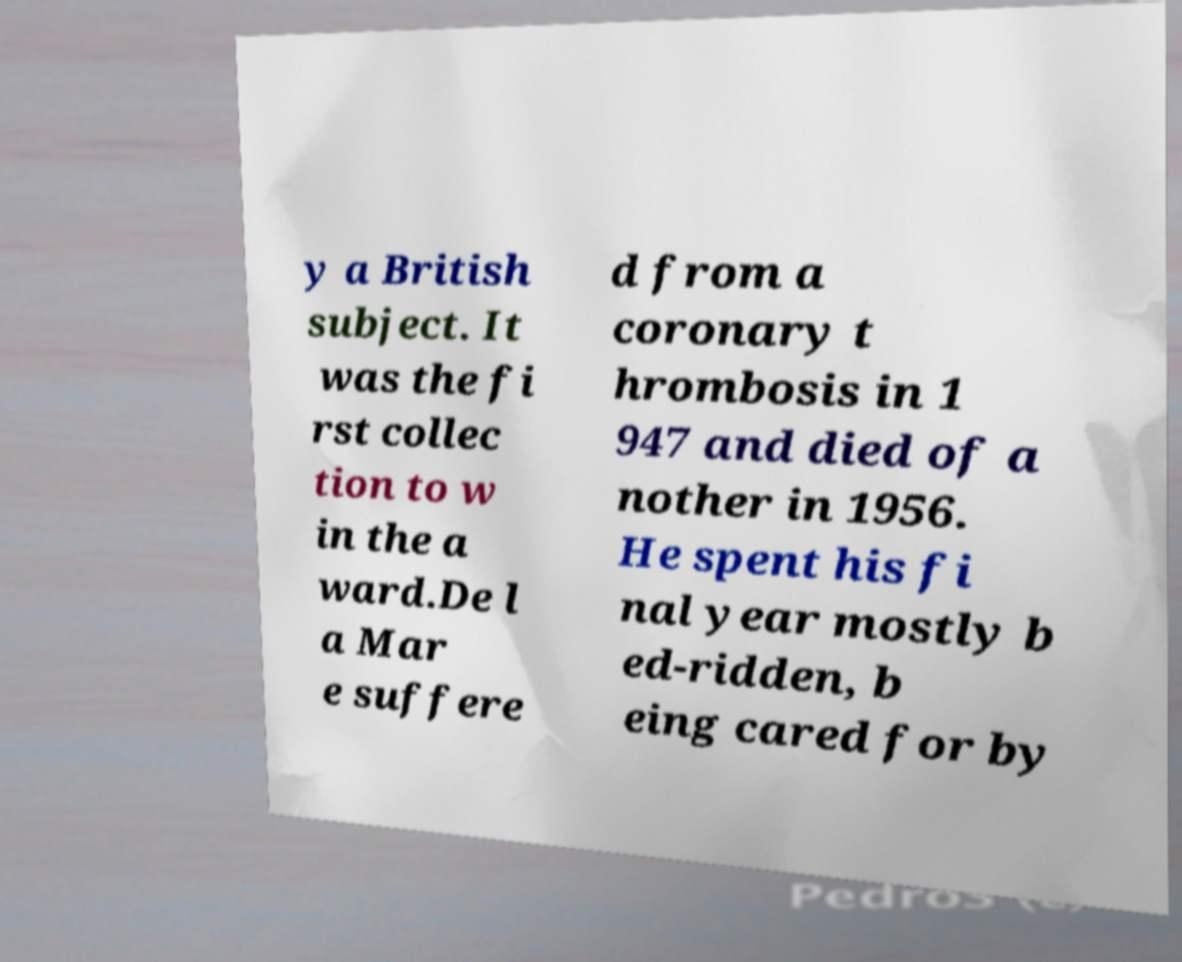What messages or text are displayed in this image? I need them in a readable, typed format. y a British subject. It was the fi rst collec tion to w in the a ward.De l a Mar e suffere d from a coronary t hrombosis in 1 947 and died of a nother in 1956. He spent his fi nal year mostly b ed-ridden, b eing cared for by 